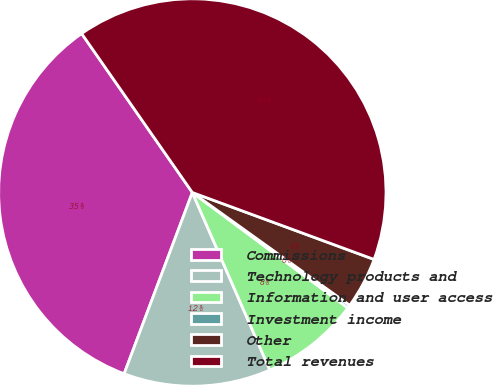Convert chart. <chart><loc_0><loc_0><loc_500><loc_500><pie_chart><fcel>Commissions<fcel>Technology products and<fcel>Information and user access<fcel>Investment income<fcel>Other<fcel>Total revenues<nl><fcel>34.59%<fcel>12.28%<fcel>8.28%<fcel>0.27%<fcel>4.28%<fcel>40.3%<nl></chart> 